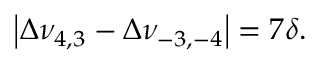Convert formula to latex. <formula><loc_0><loc_0><loc_500><loc_500>\left | \Delta \nu _ { 4 , 3 } - \Delta \nu _ { - 3 , - 4 } \right | = 7 \delta .</formula> 